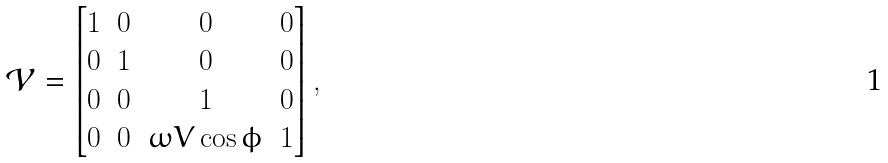<formula> <loc_0><loc_0><loc_500><loc_500>\mathcal { V } = \begin{bmatrix} 1 & 0 & 0 & 0 \\ 0 & 1 & 0 & 0 \\ 0 & 0 & 1 & 0 \\ 0 & 0 & \omega V \cos \phi & 1 \end{bmatrix} ,</formula> 